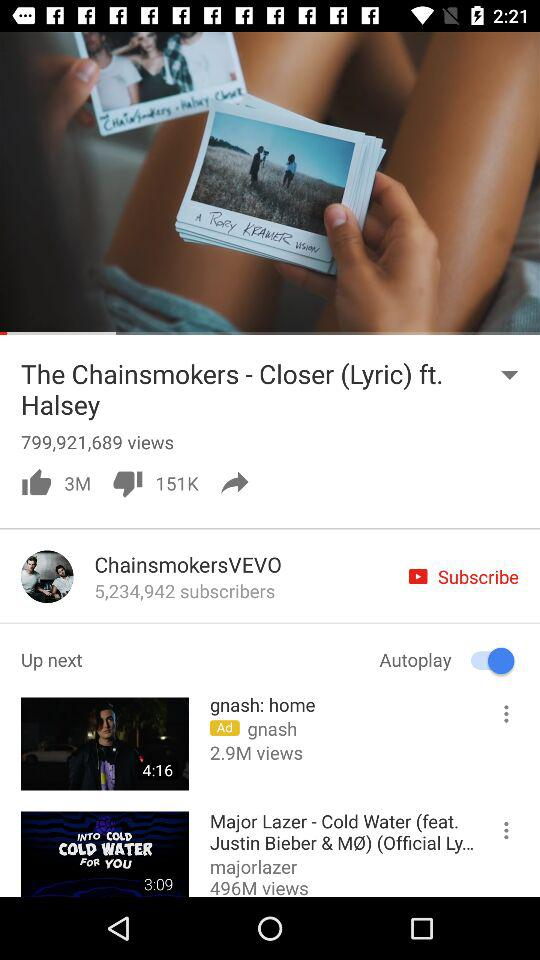How many views on the video "The Chainsmokers - Closer (Lyric) ft. Halsey"? There are 799,921,689 views. 